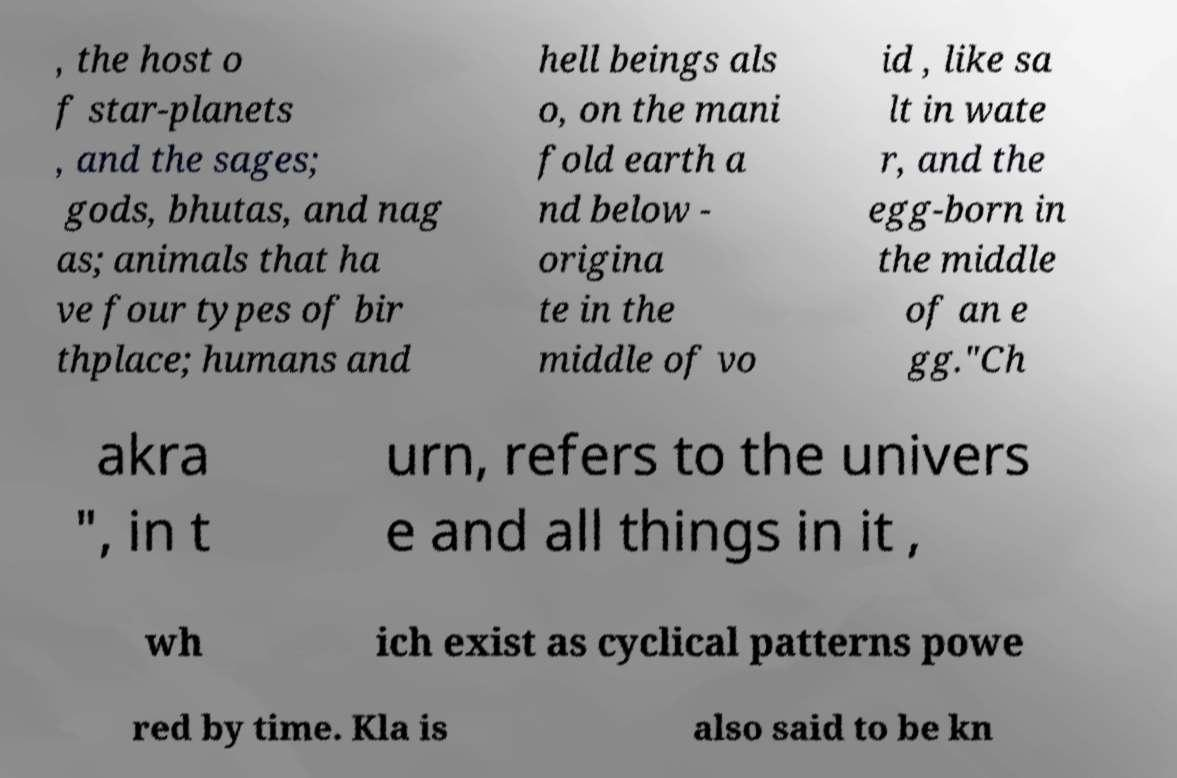I need the written content from this picture converted into text. Can you do that? , the host o f star-planets , and the sages; gods, bhutas, and nag as; animals that ha ve four types of bir thplace; humans and hell beings als o, on the mani fold earth a nd below - origina te in the middle of vo id , like sa lt in wate r, and the egg-born in the middle of an e gg."Ch akra ", in t urn, refers to the univers e and all things in it , wh ich exist as cyclical patterns powe red by time. Kla is also said to be kn 